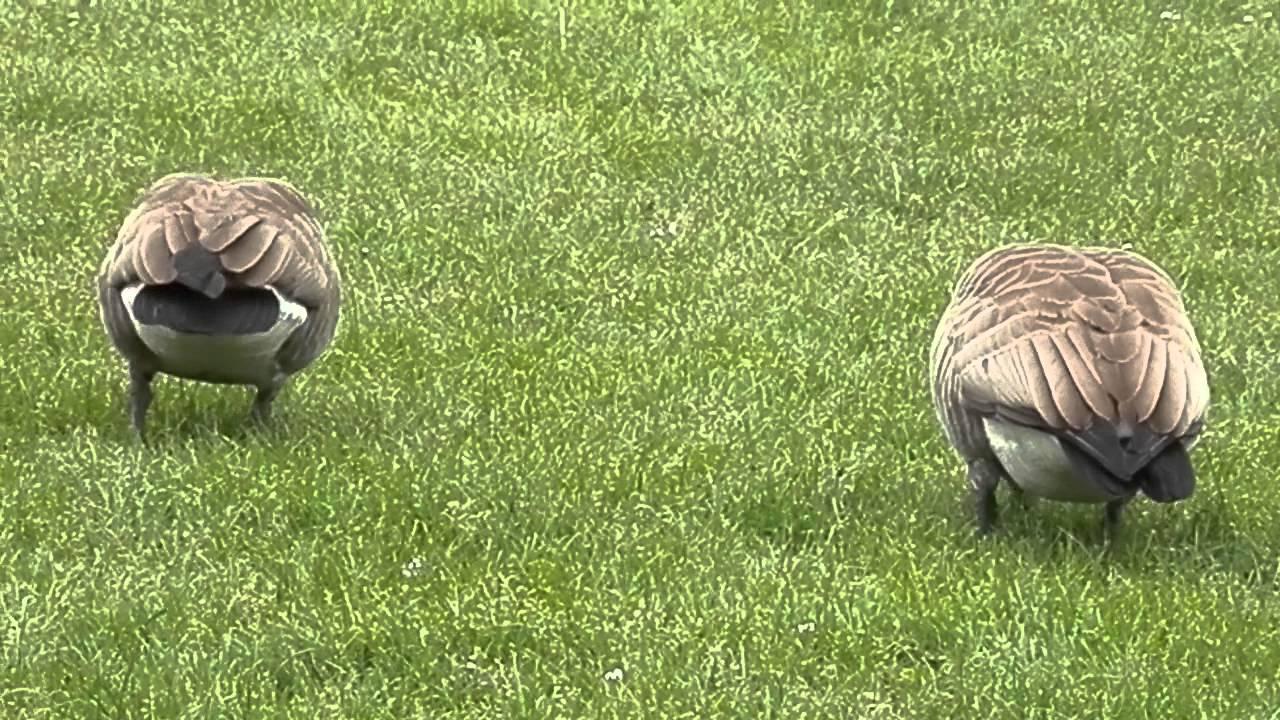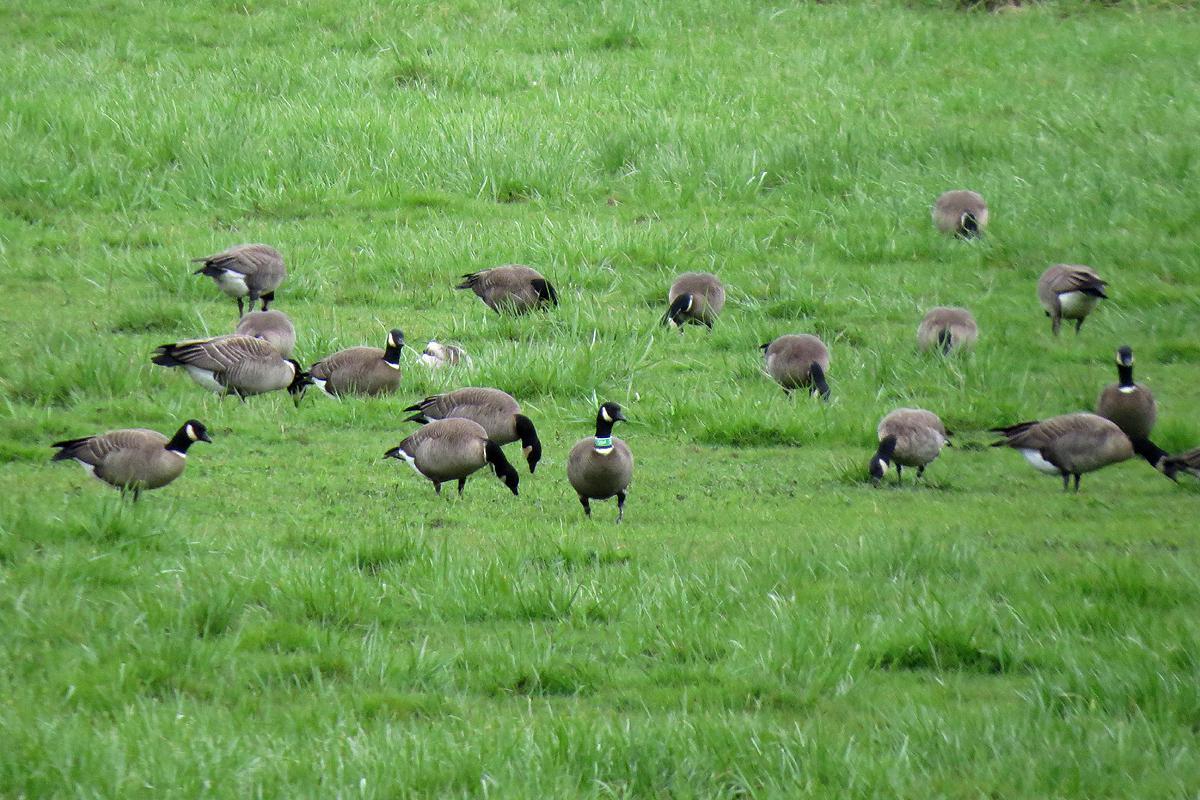The first image is the image on the left, the second image is the image on the right. Analyze the images presented: Is the assertion "One image contains one grey goose with a grey neck who is standing upright with tucked wings, and the other image includes exactly two black necked geese with at least one bending its neck to the grass." valid? Answer yes or no. No. The first image is the image on the left, the second image is the image on the right. Assess this claim about the two images: "One of the images features a single goose with an orange beak.". Correct or not? Answer yes or no. No. 